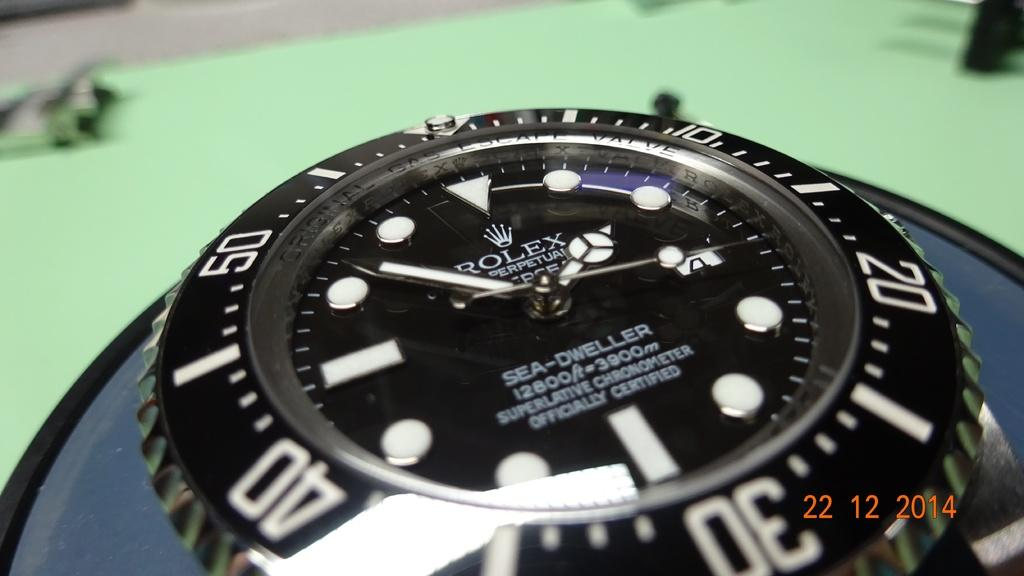<image>
Summarize the visual content of the image. A Rolex Sea-dweller watch is shown close up 